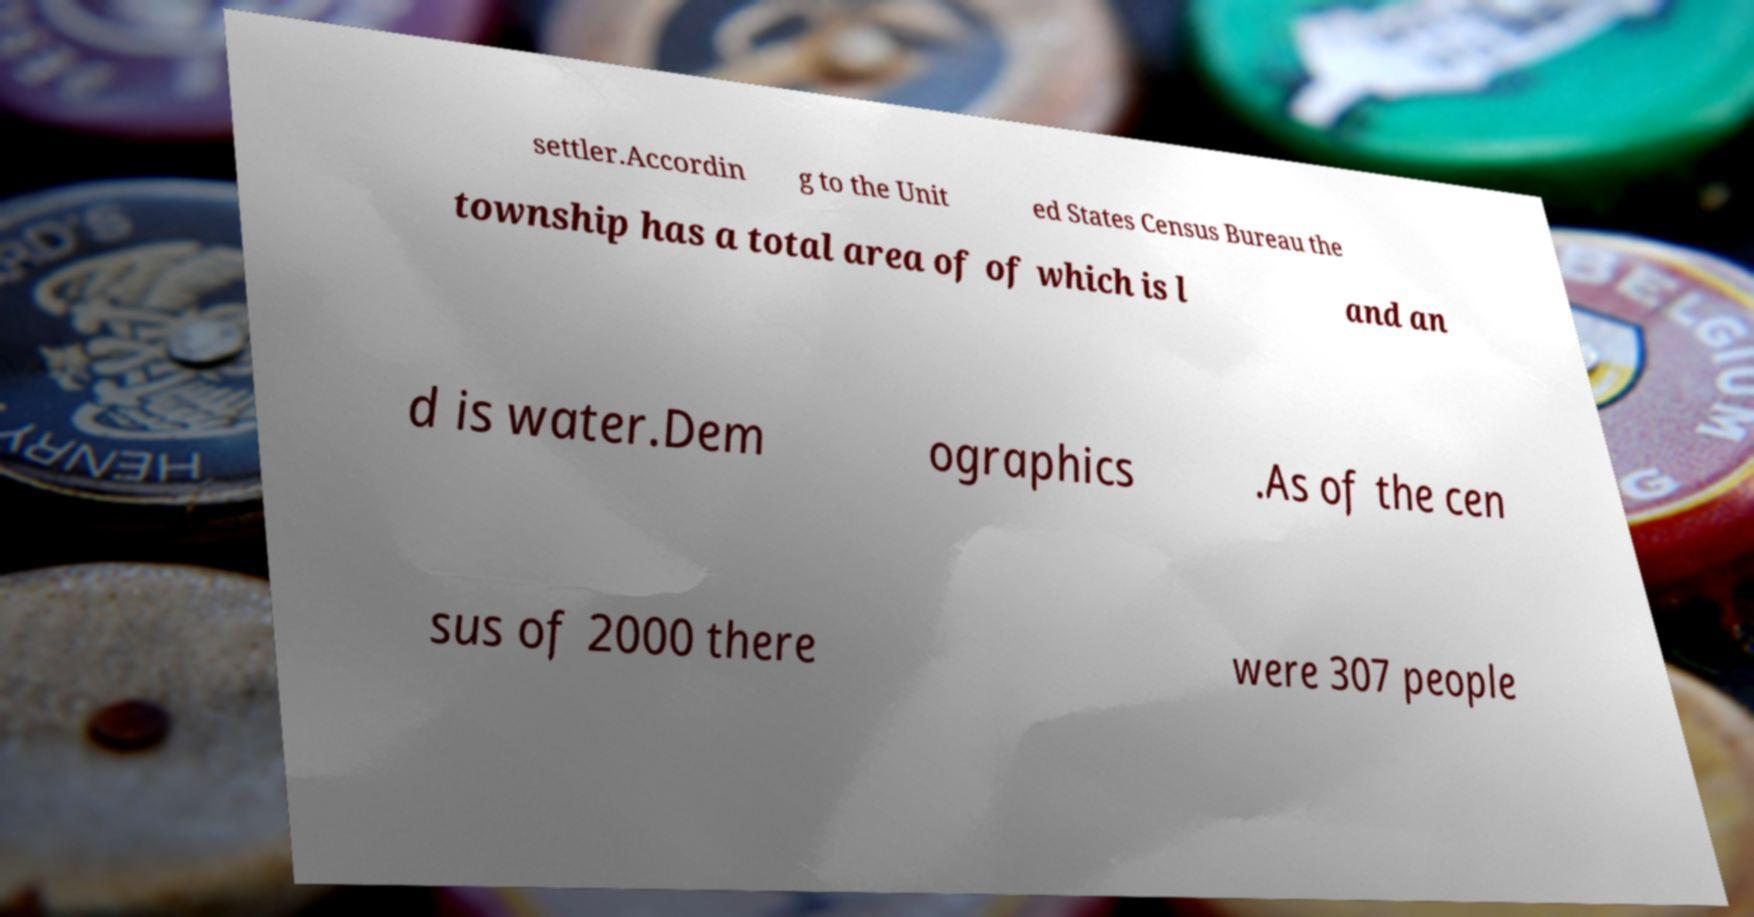Can you accurately transcribe the text from the provided image for me? settler.Accordin g to the Unit ed States Census Bureau the township has a total area of of which is l and an d is water.Dem ographics .As of the cen sus of 2000 there were 307 people 